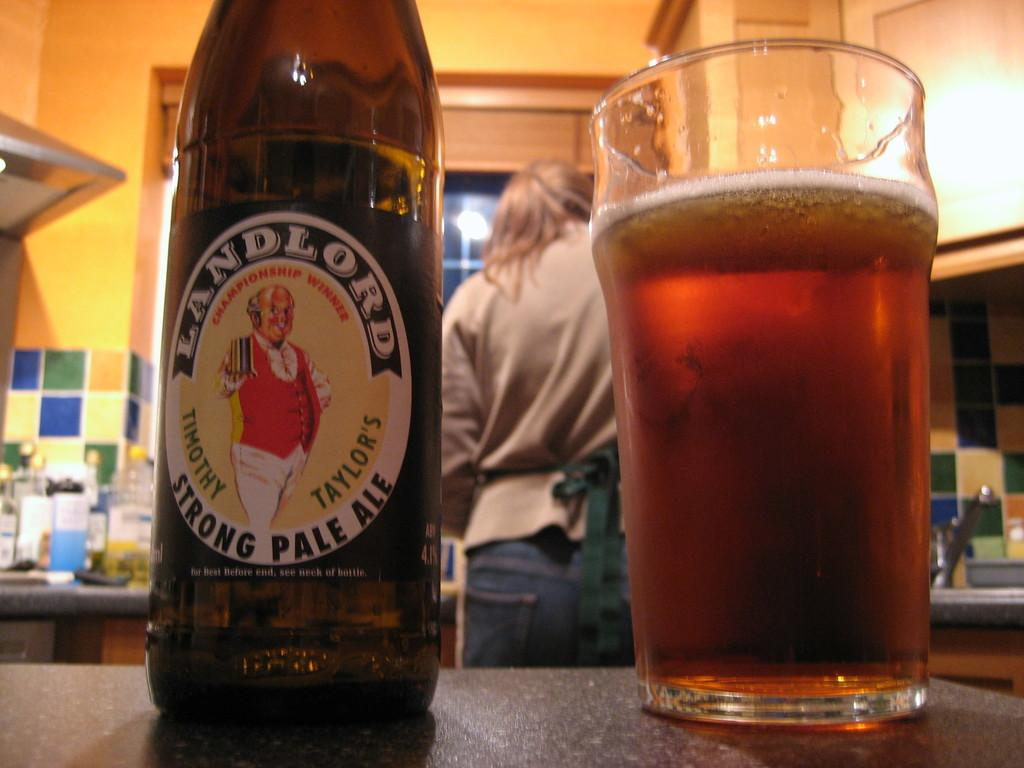<image>
Relay a brief, clear account of the picture shown. a bottle that has a label on it that says 'landlord strong pale ale' 